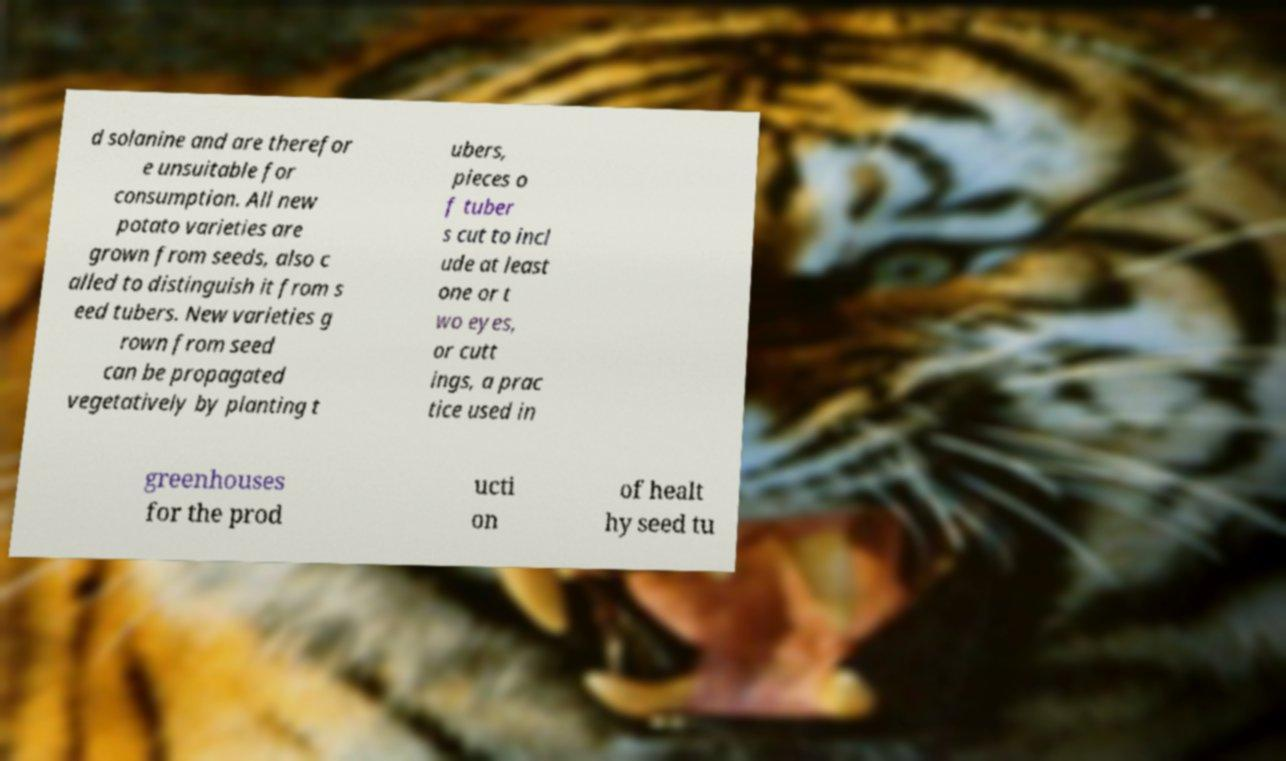There's text embedded in this image that I need extracted. Can you transcribe it verbatim? d solanine and are therefor e unsuitable for consumption. All new potato varieties are grown from seeds, also c alled to distinguish it from s eed tubers. New varieties g rown from seed can be propagated vegetatively by planting t ubers, pieces o f tuber s cut to incl ude at least one or t wo eyes, or cutt ings, a prac tice used in greenhouses for the prod ucti on of healt hy seed tu 